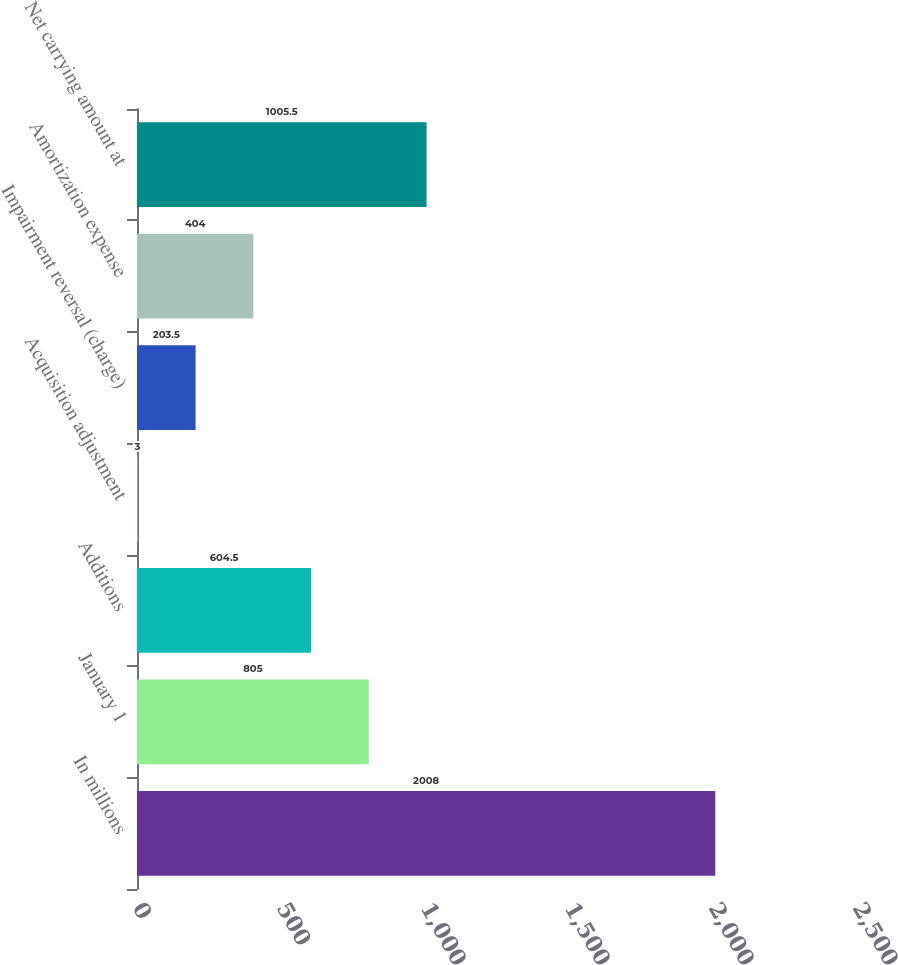Convert chart. <chart><loc_0><loc_0><loc_500><loc_500><bar_chart><fcel>In millions<fcel>January 1<fcel>Additions<fcel>Acquisition adjustment<fcel>Impairment reversal (charge)<fcel>Amortization expense<fcel>Net carrying amount at<nl><fcel>2008<fcel>805<fcel>604.5<fcel>3<fcel>203.5<fcel>404<fcel>1005.5<nl></chart> 